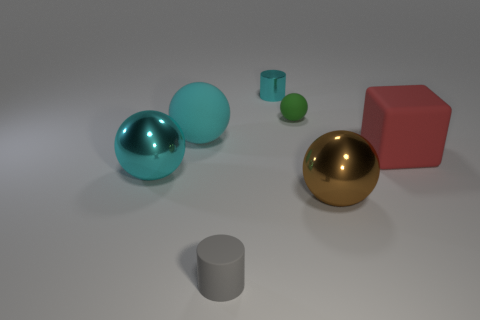Subtract all big brown balls. How many balls are left? 3 Subtract all green blocks. How many cyan spheres are left? 2 Subtract all green spheres. How many spheres are left? 3 Add 3 big green matte spheres. How many objects exist? 10 Subtract all yellow spheres. Subtract all red cubes. How many spheres are left? 4 Subtract all spheres. How many objects are left? 3 Subtract 0 gray spheres. How many objects are left? 7 Subtract all gray matte cylinders. Subtract all small cyan metal things. How many objects are left? 5 Add 4 big rubber cubes. How many big rubber cubes are left? 5 Add 6 small cyan things. How many small cyan things exist? 7 